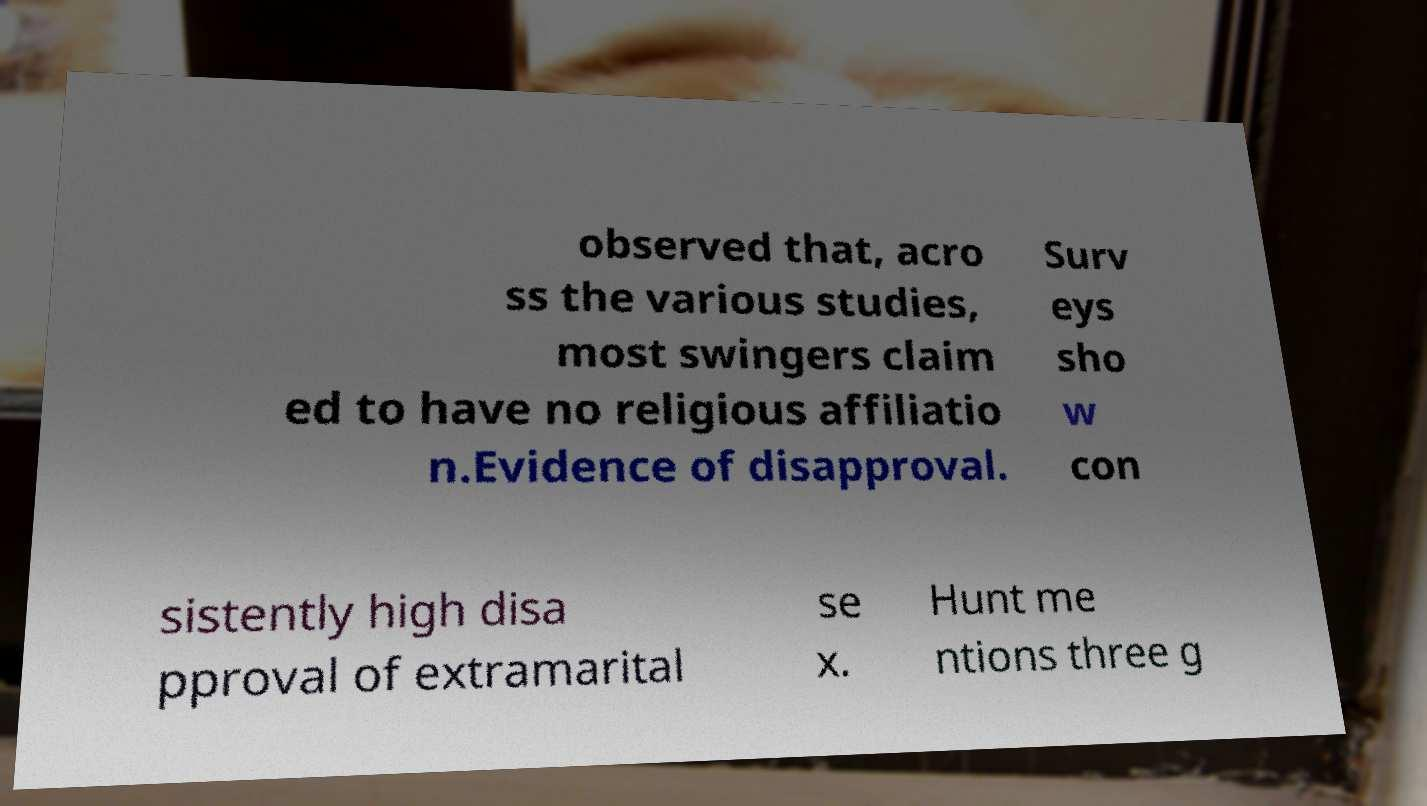Please read and relay the text visible in this image. What does it say? observed that, acro ss the various studies, most swingers claim ed to have no religious affiliatio n.Evidence of disapproval. Surv eys sho w con sistently high disa pproval of extramarital se x. Hunt me ntions three g 